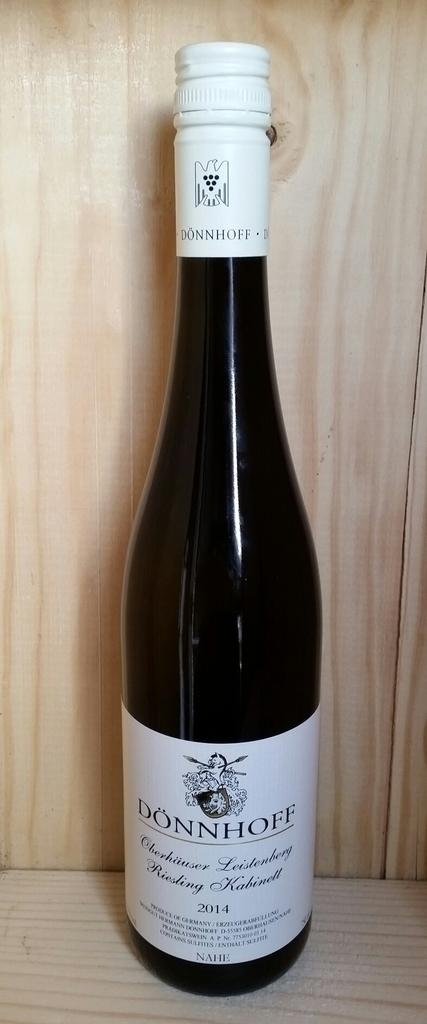<image>
Share a concise interpretation of the image provided. A bottle of Donnhoff wine from 2014 sitting on a wooden shelf 